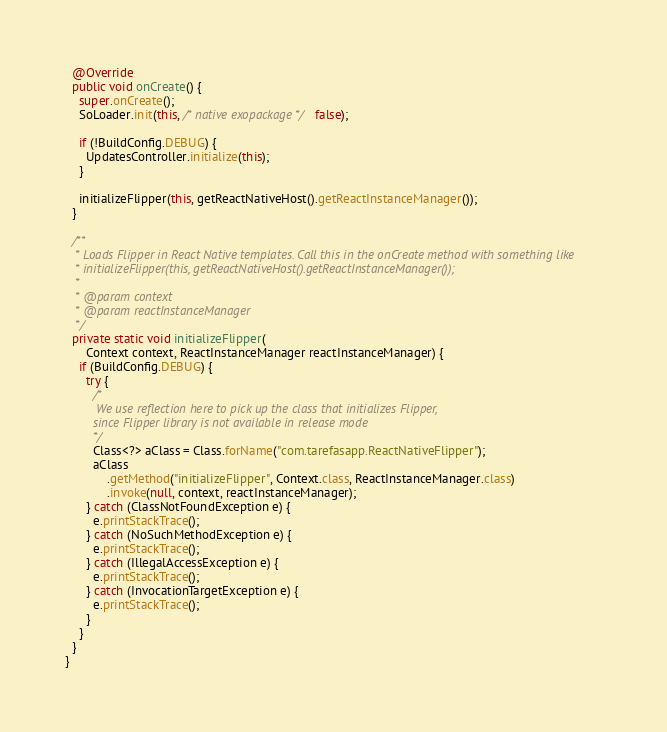Convert code to text. <code><loc_0><loc_0><loc_500><loc_500><_Java_>
  @Override
  public void onCreate() {
    super.onCreate();
    SoLoader.init(this, /* native exopackage */ false);

    if (!BuildConfig.DEBUG) {
      UpdatesController.initialize(this);
    }

    initializeFlipper(this, getReactNativeHost().getReactInstanceManager());
  }

  /**
   * Loads Flipper in React Native templates. Call this in the onCreate method with something like
   * initializeFlipper(this, getReactNativeHost().getReactInstanceManager());
   *
   * @param context
   * @param reactInstanceManager
   */
  private static void initializeFlipper(
      Context context, ReactInstanceManager reactInstanceManager) {
    if (BuildConfig.DEBUG) {
      try {
        /*
         We use reflection here to pick up the class that initializes Flipper,
        since Flipper library is not available in release mode
        */
        Class<?> aClass = Class.forName("com.tarefasapp.ReactNativeFlipper");
        aClass
            .getMethod("initializeFlipper", Context.class, ReactInstanceManager.class)
            .invoke(null, context, reactInstanceManager);
      } catch (ClassNotFoundException e) {
        e.printStackTrace();
      } catch (NoSuchMethodException e) {
        e.printStackTrace();
      } catch (IllegalAccessException e) {
        e.printStackTrace();
      } catch (InvocationTargetException e) {
        e.printStackTrace();
      }
    }
  }
}
</code> 